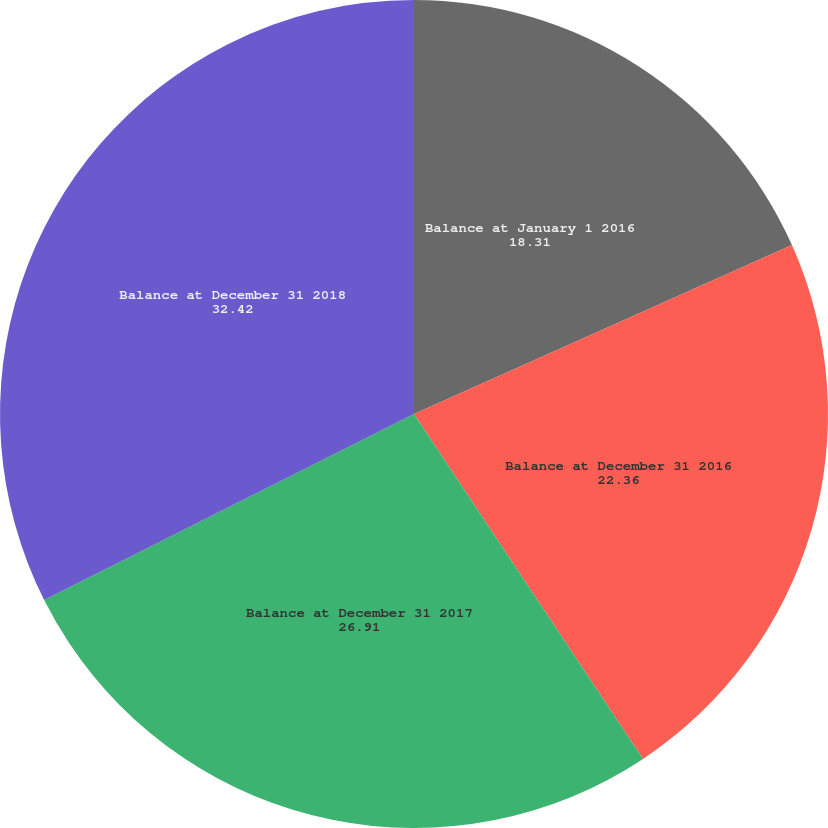Convert chart. <chart><loc_0><loc_0><loc_500><loc_500><pie_chart><fcel>Balance at January 1 2016<fcel>Balance at December 31 2016<fcel>Balance at December 31 2017<fcel>Balance at December 31 2018<nl><fcel>18.31%<fcel>22.36%<fcel>26.91%<fcel>32.42%<nl></chart> 